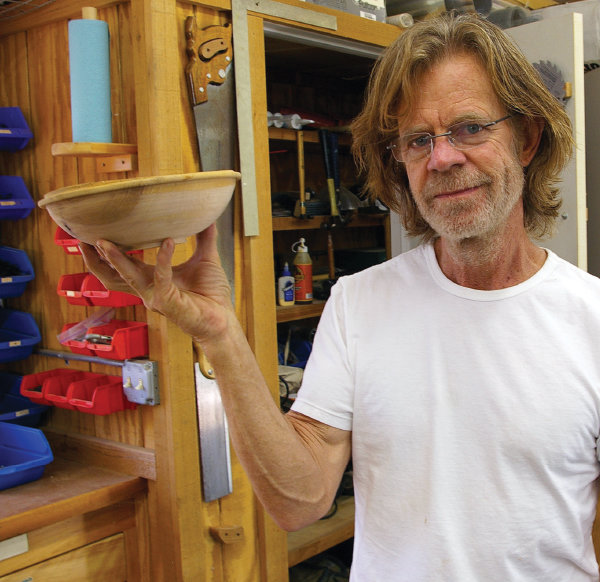How does the man's expression and posture in the image contribute to the overall atmosphere or theme of the scene? The man's slight smile and direct gaze into the camera convey a sense of pride and satisfaction in his work, which lends an inviting and warm atmosphere to the scene. His posture, holding a bowl with one hand confidently, exudes a casual ease and competence. These elements together portray a scene not just of craftsmanship but also of personal fulfillment and joy found in the art of woodworking, highlighting the more intimate and personal side of engaging in such a hobby. 